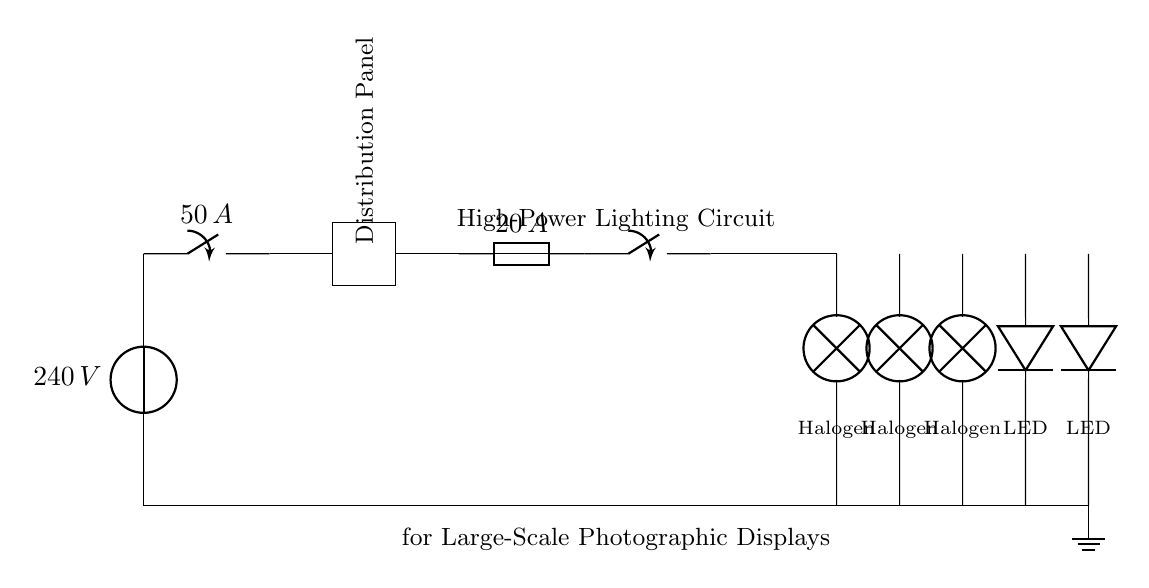What is the voltage of the circuit? The voltage is 240 volts, as indicated next to the voltage source at the beginning of the circuit diagram.
Answer: 240 volts What is the rating of the circuit breaker? The circuit breaker is rated at 50 amperes, which is specified on the circuit diagram next to the closing switch symbol.
Answer: 50 amperes How many halogen floodlights are included in the circuit? There are three halogen floodlights connected in parallel, which can be visually confirmed by counting the lamp symbols on the diagram.
Answer: Three What is the rating of the fuse used in the lighting circuit? The fuse is rated at 20 amperes, clearly labeled next to the fuse symbol in the circuit diagram.
Answer: 20 amperes What type of lights are used in addition to halogen floodlights? LED strip lights are also used in the circuit, indicated by the diode symbols in the diagram.
Answer: LED strip lights Which component connects the circuit to the ground? The ground is connected through the ground symbol at the bottom of the diagram, showing the circuit's connection to earth ground.
Answer: Ground How does the distribution panel interact with the lighting circuits? The distribution panel distributes the electrical supply to various lighting circuits, as shown by the connection from the distribution panel to the lighting circuit path.
Answer: It distributes power 